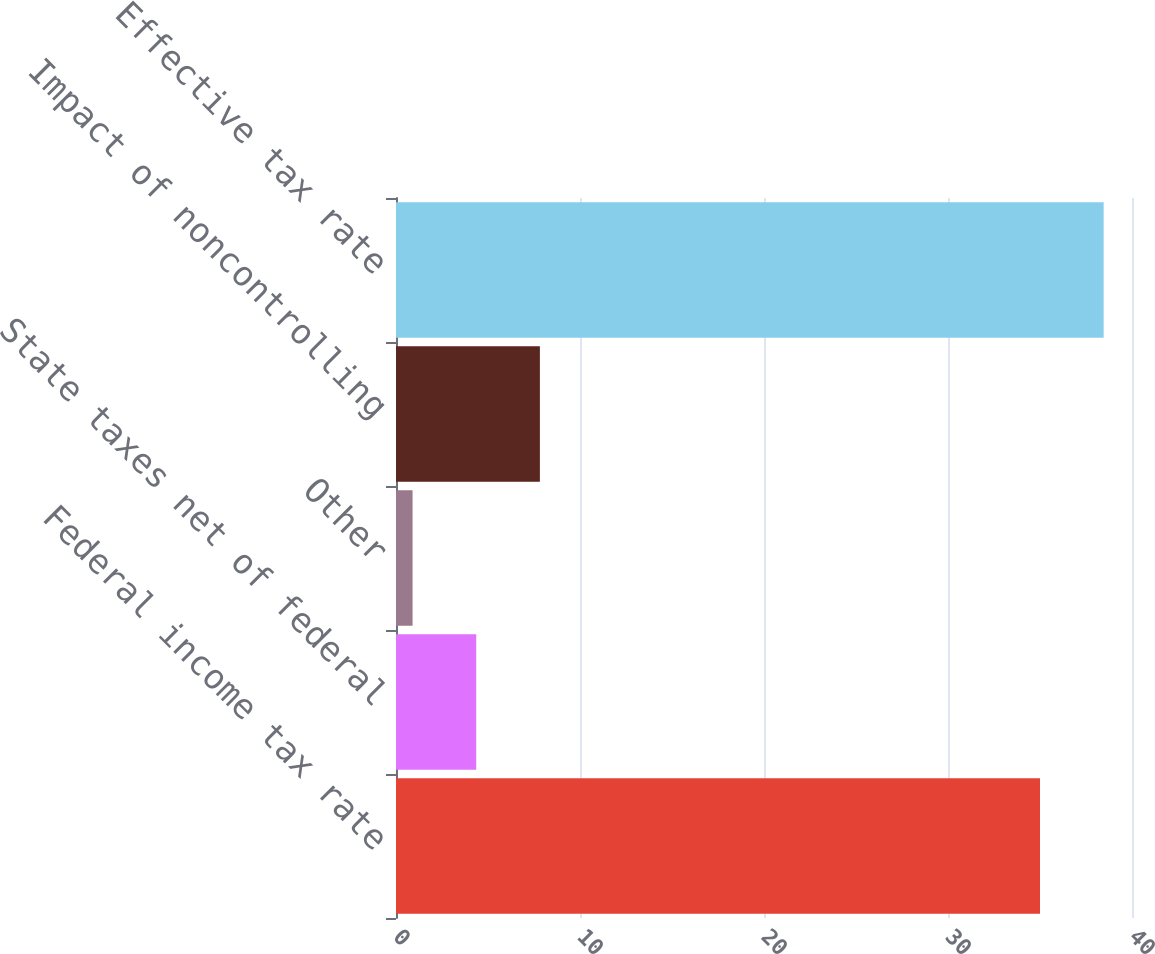Convert chart. <chart><loc_0><loc_0><loc_500><loc_500><bar_chart><fcel>Federal income tax rate<fcel>State taxes net of federal<fcel>Other<fcel>Impact of noncontrolling<fcel>Effective tax rate<nl><fcel>35<fcel>4.36<fcel>0.9<fcel>7.82<fcel>38.46<nl></chart> 